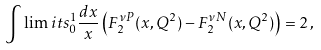Convert formula to latex. <formula><loc_0><loc_0><loc_500><loc_500>\int \lim i t s _ { 0 } ^ { 1 } \frac { d x } { x } \left ( F _ { 2 } ^ { \nu P } ( x , Q ^ { 2 } ) - F _ { 2 } ^ { \nu N } ( x , Q ^ { 2 } ) \right ) = 2 \, ,</formula> 